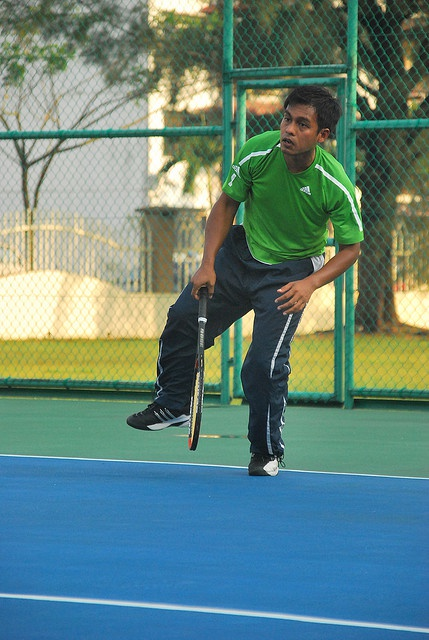Describe the objects in this image and their specific colors. I can see people in darkgreen, black, brown, and darkblue tones and tennis racket in darkgreen, black, gray, darkgray, and purple tones in this image. 